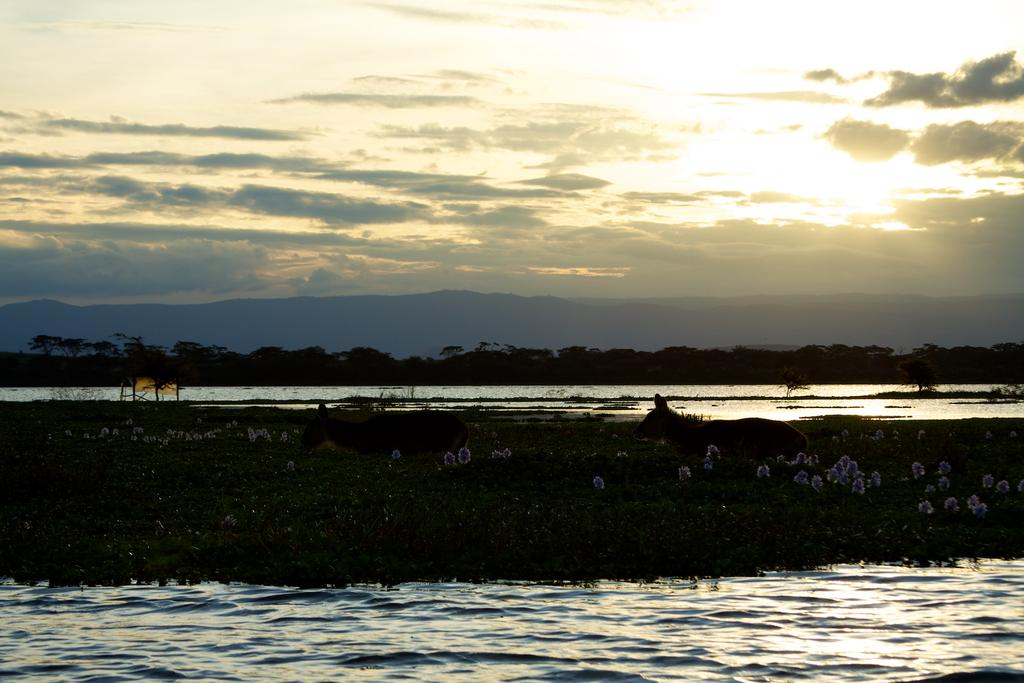What is present at the bottom of the image? There is water at the bottom side of the image. What type of terrain is in the center of the image? There is a grassland in the center of the image. What part of the natural environment is visible at the top of the image? The sky is visible at the top side of the image. What type of songs can be heard coming from the grassland in the image? There is no indication in the image that songs are being played or heard, so it's not possible to determine what, if any, songs might be heard. 